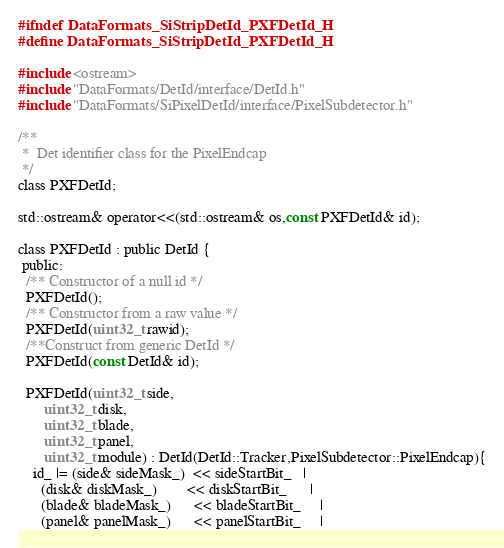Convert code to text. <code><loc_0><loc_0><loc_500><loc_500><_C_>#ifndef DataFormats_SiStripDetId_PXFDetId_H
#define DataFormats_SiStripDetId_PXFDetId_H

#include <ostream>
#include "DataFormats/DetId/interface/DetId.h"
#include "DataFormats/SiPixelDetId/interface/PixelSubdetector.h"

/** 
 *  Det identifier class for the PixelEndcap
 */
class PXFDetId;

std::ostream& operator<<(std::ostream& os,const PXFDetId& id);

class PXFDetId : public DetId {
 public:
  /** Constructor of a null id */
  PXFDetId();
  /** Constructor from a raw value */
  PXFDetId(uint32_t rawid);
  /**Construct from generic DetId */
  PXFDetId(const DetId& id); 
  
  PXFDetId(uint32_t side,
	   uint32_t disk,
	   uint32_t blade,
	   uint32_t panel,
	   uint32_t module) : DetId(DetId::Tracker,PixelSubdetector::PixelEndcap){
    id_ |= (side& sideMask_)  << sideStartBit_   |
      (disk& diskMask_)        << diskStartBit_      |
      (blade& bladeMask_)      << bladeStartBit_     |
      (panel& panelMask_)      << panelStartBit_     |</code> 